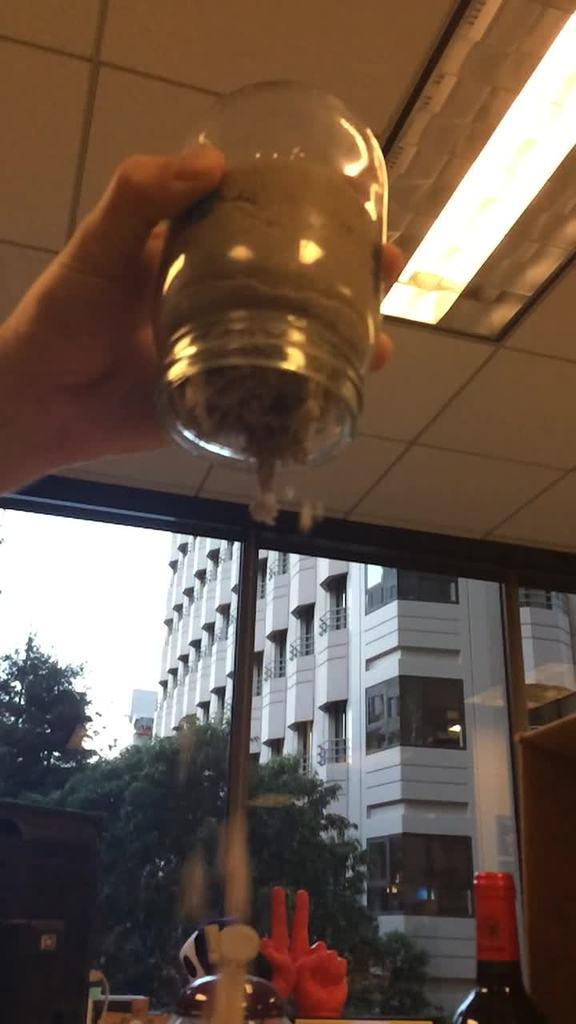What is the person in the image holding? The person is holding a container in the image. What else can be seen in the image besides the person? There is a bottle, trees, a building, and the sky visible in the image. Can you describe the natural elements in the image? There are trees in the image, and the sky is visible. What type of structure is present in the image? There is a building in the image. What type of net is being used by the animal in the image? There is no animal or net present in the image. Is the person wearing a crown in the image? There is no crown visible in the image. 